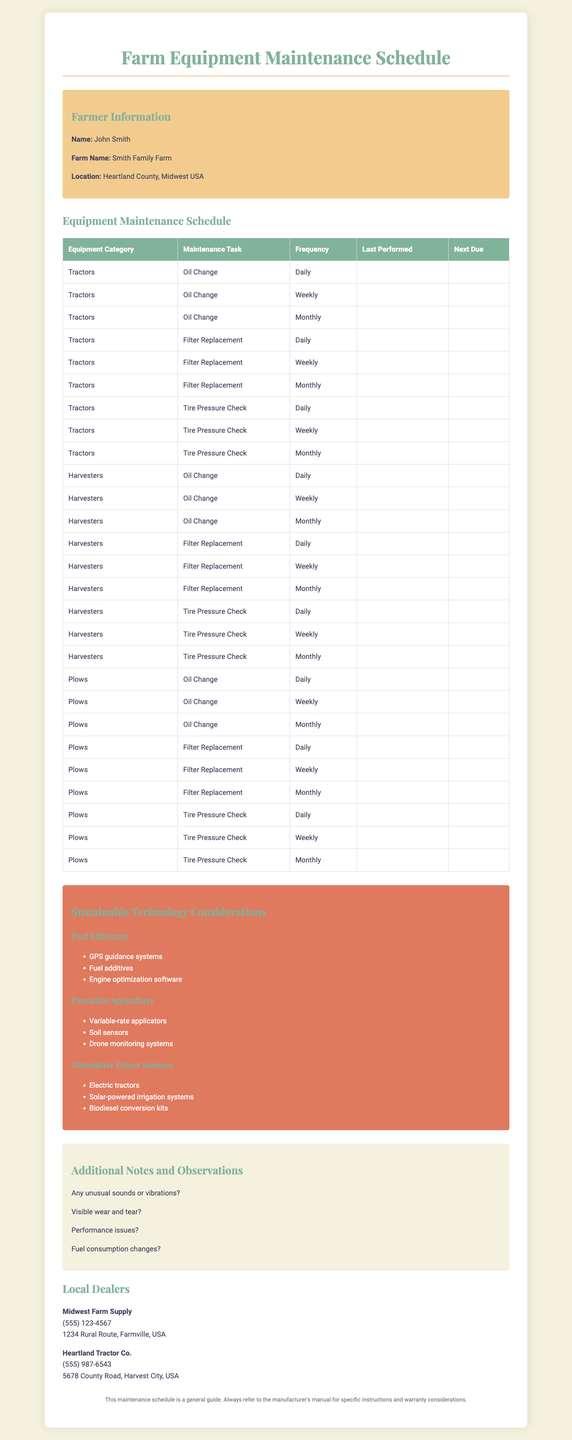What is the name of the farmer? The farmer's name is listed in the farmer information section.
Answer: John Smith What is the purpose of the maintenance schedule? The purpose is to provide guidance on how to maintain farm equipment properly.
Answer: Equipment maintenance Which equipment category is not mentioned? The question is looking for any category not listed in the equipment section.
Answer: None (all categories are mentioned) How often should tire pressure checks be performed? Maintenance frequency options show how often specific tasks should be done.
Answer: As Needed What types of fuel efficiency technologies are suggested? This question refers to the sustainable technology considerations in the document.
Answer: GPS guidance systems, fuel additives, engine optimization software What is the address of the local dealer? The address of the dealer is needed for contacting them for parts or services.
Answer: 1234 Rural Route, Farmville, USA What should you check if there are unusual sounds? This question involves identification of maintenance tasks related to sounds.
Answer: Inspection What is the last maintenance task listed? The document's structure indicates the last task listed in the maintenance table.
Answer: Calibration Who is the second local dealer mentioned? This asks for specific information about the dealer from the local dealers section.
Answer: Heartland Tractor Co What is included in the cost-tracking categories? The question is about cost tracking and what aspects of maintenance are monitored.
Answer: Parts, Labor, Downtime, Fuel 